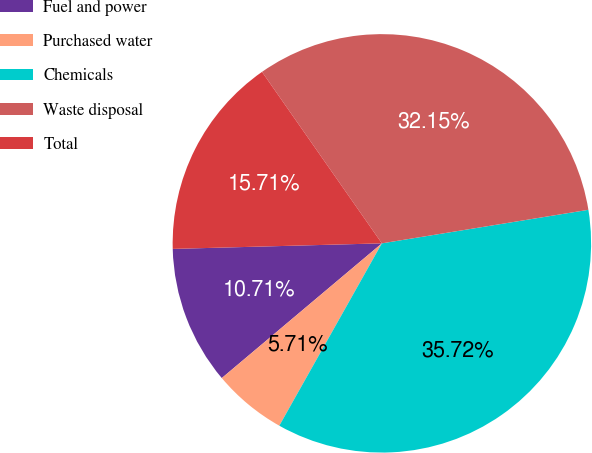<chart> <loc_0><loc_0><loc_500><loc_500><pie_chart><fcel>Fuel and power<fcel>Purchased water<fcel>Chemicals<fcel>Waste disposal<fcel>Total<nl><fcel>10.71%<fcel>5.71%<fcel>35.71%<fcel>32.14%<fcel>15.71%<nl></chart> 